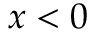Convert formula to latex. <formula><loc_0><loc_0><loc_500><loc_500>x < 0</formula> 